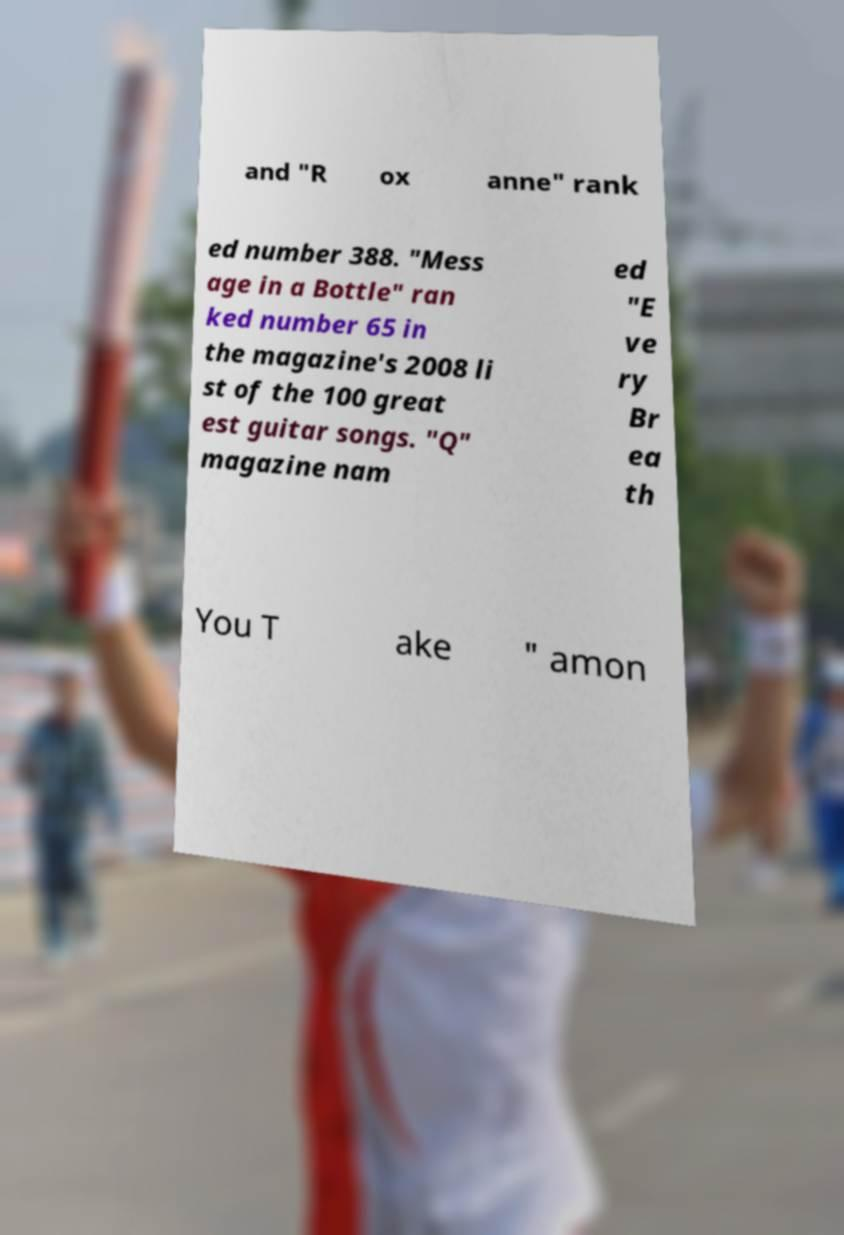I need the written content from this picture converted into text. Can you do that? and "R ox anne" rank ed number 388. "Mess age in a Bottle" ran ked number 65 in the magazine's 2008 li st of the 100 great est guitar songs. "Q" magazine nam ed "E ve ry Br ea th You T ake " amon 